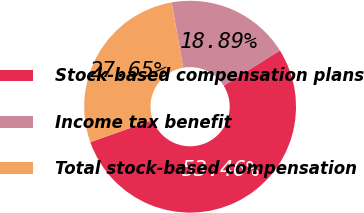Convert chart. <chart><loc_0><loc_0><loc_500><loc_500><pie_chart><fcel>Stock-based compensation plans<fcel>Income tax benefit<fcel>Total stock-based compensation<nl><fcel>53.46%<fcel>18.89%<fcel>27.65%<nl></chart> 